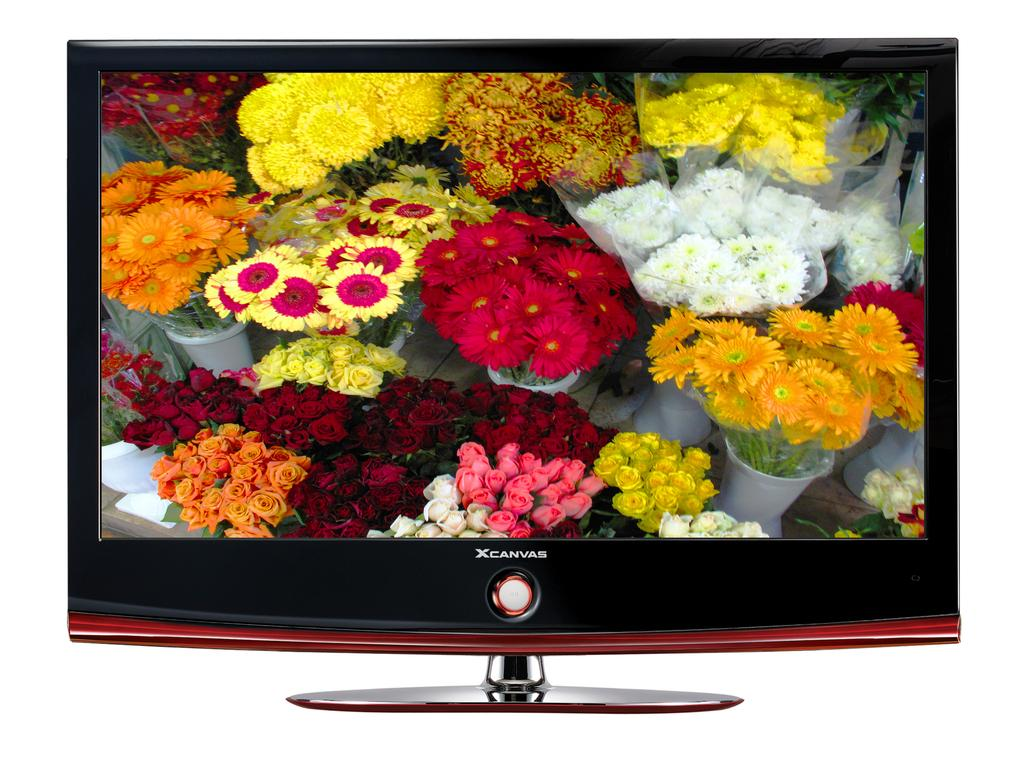<image>
Give a short and clear explanation of the subsequent image. a canvas television that has flowers on it 